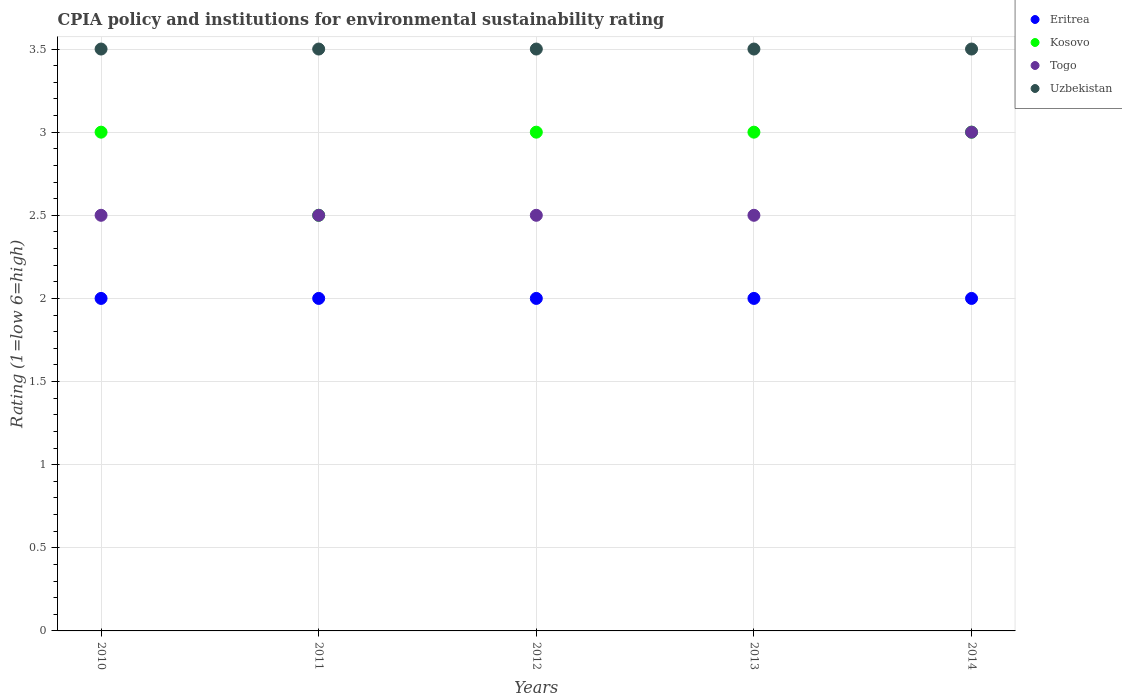Across all years, what is the maximum CPIA rating in Uzbekistan?
Make the answer very short. 3.5. Across all years, what is the minimum CPIA rating in Eritrea?
Your answer should be very brief. 2. In which year was the CPIA rating in Eritrea maximum?
Give a very brief answer. 2010. In which year was the CPIA rating in Togo minimum?
Give a very brief answer. 2010. What is the total CPIA rating in Uzbekistan in the graph?
Offer a terse response. 17.5. What is the difference between the CPIA rating in Togo in 2010 and that in 2014?
Your response must be concise. -0.5. In the year 2012, what is the difference between the CPIA rating in Kosovo and CPIA rating in Eritrea?
Your response must be concise. 1. Is the CPIA rating in Togo in 2012 less than that in 2014?
Your response must be concise. Yes. What is the difference between the highest and the second highest CPIA rating in Togo?
Your response must be concise. 0.5. What is the difference between the highest and the lowest CPIA rating in Togo?
Make the answer very short. 0.5. Is it the case that in every year, the sum of the CPIA rating in Uzbekistan and CPIA rating in Togo  is greater than the CPIA rating in Eritrea?
Keep it short and to the point. Yes. Is the CPIA rating in Togo strictly greater than the CPIA rating in Eritrea over the years?
Give a very brief answer. Yes. Is the CPIA rating in Uzbekistan strictly less than the CPIA rating in Kosovo over the years?
Offer a terse response. No. How many dotlines are there?
Offer a very short reply. 4. How many years are there in the graph?
Your answer should be very brief. 5. Does the graph contain any zero values?
Your answer should be compact. No. Where does the legend appear in the graph?
Provide a short and direct response. Top right. How many legend labels are there?
Your answer should be compact. 4. How are the legend labels stacked?
Offer a very short reply. Vertical. What is the title of the graph?
Ensure brevity in your answer.  CPIA policy and institutions for environmental sustainability rating. Does "Jamaica" appear as one of the legend labels in the graph?
Your response must be concise. No. What is the Rating (1=low 6=high) in Eritrea in 2011?
Make the answer very short. 2. What is the Rating (1=low 6=high) of Kosovo in 2011?
Your response must be concise. 2.5. What is the Rating (1=low 6=high) of Togo in 2011?
Keep it short and to the point. 2.5. What is the Rating (1=low 6=high) in Kosovo in 2013?
Your answer should be very brief. 3. Across all years, what is the maximum Rating (1=low 6=high) of Kosovo?
Make the answer very short. 3. Across all years, what is the maximum Rating (1=low 6=high) of Togo?
Keep it short and to the point. 3. Across all years, what is the maximum Rating (1=low 6=high) of Uzbekistan?
Ensure brevity in your answer.  3.5. Across all years, what is the minimum Rating (1=low 6=high) in Kosovo?
Your answer should be very brief. 2.5. What is the total Rating (1=low 6=high) of Eritrea in the graph?
Offer a very short reply. 10. What is the total Rating (1=low 6=high) of Togo in the graph?
Make the answer very short. 13. What is the total Rating (1=low 6=high) of Uzbekistan in the graph?
Offer a very short reply. 17.5. What is the difference between the Rating (1=low 6=high) in Kosovo in 2010 and that in 2011?
Provide a succinct answer. 0.5. What is the difference between the Rating (1=low 6=high) in Uzbekistan in 2010 and that in 2011?
Your response must be concise. 0. What is the difference between the Rating (1=low 6=high) of Kosovo in 2010 and that in 2012?
Provide a succinct answer. 0. What is the difference between the Rating (1=low 6=high) of Togo in 2010 and that in 2012?
Offer a very short reply. 0. What is the difference between the Rating (1=low 6=high) in Uzbekistan in 2010 and that in 2012?
Make the answer very short. 0. What is the difference between the Rating (1=low 6=high) of Kosovo in 2010 and that in 2014?
Your answer should be very brief. 0. What is the difference between the Rating (1=low 6=high) in Uzbekistan in 2010 and that in 2014?
Offer a very short reply. 0. What is the difference between the Rating (1=low 6=high) in Eritrea in 2011 and that in 2012?
Give a very brief answer. 0. What is the difference between the Rating (1=low 6=high) of Togo in 2011 and that in 2012?
Provide a short and direct response. 0. What is the difference between the Rating (1=low 6=high) of Uzbekistan in 2011 and that in 2012?
Your response must be concise. 0. What is the difference between the Rating (1=low 6=high) of Eritrea in 2011 and that in 2013?
Provide a short and direct response. 0. What is the difference between the Rating (1=low 6=high) in Kosovo in 2011 and that in 2013?
Ensure brevity in your answer.  -0.5. What is the difference between the Rating (1=low 6=high) in Eritrea in 2012 and that in 2013?
Your response must be concise. 0. What is the difference between the Rating (1=low 6=high) in Kosovo in 2012 and that in 2013?
Keep it short and to the point. 0. What is the difference between the Rating (1=low 6=high) in Togo in 2012 and that in 2013?
Offer a terse response. 0. What is the difference between the Rating (1=low 6=high) in Uzbekistan in 2012 and that in 2013?
Offer a very short reply. 0. What is the difference between the Rating (1=low 6=high) in Togo in 2012 and that in 2014?
Provide a succinct answer. -0.5. What is the difference between the Rating (1=low 6=high) in Kosovo in 2013 and that in 2014?
Your response must be concise. 0. What is the difference between the Rating (1=low 6=high) in Togo in 2013 and that in 2014?
Give a very brief answer. -0.5. What is the difference between the Rating (1=low 6=high) in Eritrea in 2010 and the Rating (1=low 6=high) in Togo in 2011?
Provide a short and direct response. -0.5. What is the difference between the Rating (1=low 6=high) in Kosovo in 2010 and the Rating (1=low 6=high) in Uzbekistan in 2011?
Your response must be concise. -0.5. What is the difference between the Rating (1=low 6=high) in Eritrea in 2010 and the Rating (1=low 6=high) in Togo in 2012?
Keep it short and to the point. -0.5. What is the difference between the Rating (1=low 6=high) in Eritrea in 2010 and the Rating (1=low 6=high) in Uzbekistan in 2012?
Provide a short and direct response. -1.5. What is the difference between the Rating (1=low 6=high) of Kosovo in 2010 and the Rating (1=low 6=high) of Uzbekistan in 2012?
Your answer should be compact. -0.5. What is the difference between the Rating (1=low 6=high) of Eritrea in 2010 and the Rating (1=low 6=high) of Togo in 2013?
Your response must be concise. -0.5. What is the difference between the Rating (1=low 6=high) in Eritrea in 2010 and the Rating (1=low 6=high) in Uzbekistan in 2013?
Keep it short and to the point. -1.5. What is the difference between the Rating (1=low 6=high) of Kosovo in 2010 and the Rating (1=low 6=high) of Uzbekistan in 2013?
Offer a very short reply. -0.5. What is the difference between the Rating (1=low 6=high) of Eritrea in 2010 and the Rating (1=low 6=high) of Kosovo in 2014?
Make the answer very short. -1. What is the difference between the Rating (1=low 6=high) of Kosovo in 2010 and the Rating (1=low 6=high) of Togo in 2014?
Keep it short and to the point. 0. What is the difference between the Rating (1=low 6=high) in Togo in 2010 and the Rating (1=low 6=high) in Uzbekistan in 2014?
Provide a short and direct response. -1. What is the difference between the Rating (1=low 6=high) in Eritrea in 2011 and the Rating (1=low 6=high) in Togo in 2012?
Ensure brevity in your answer.  -0.5. What is the difference between the Rating (1=low 6=high) of Kosovo in 2011 and the Rating (1=low 6=high) of Togo in 2012?
Provide a short and direct response. 0. What is the difference between the Rating (1=low 6=high) in Togo in 2011 and the Rating (1=low 6=high) in Uzbekistan in 2012?
Offer a terse response. -1. What is the difference between the Rating (1=low 6=high) of Eritrea in 2011 and the Rating (1=low 6=high) of Kosovo in 2013?
Your response must be concise. -1. What is the difference between the Rating (1=low 6=high) in Eritrea in 2011 and the Rating (1=low 6=high) in Togo in 2013?
Offer a very short reply. -0.5. What is the difference between the Rating (1=low 6=high) of Eritrea in 2011 and the Rating (1=low 6=high) of Uzbekistan in 2013?
Offer a terse response. -1.5. What is the difference between the Rating (1=low 6=high) in Kosovo in 2011 and the Rating (1=low 6=high) in Uzbekistan in 2013?
Give a very brief answer. -1. What is the difference between the Rating (1=low 6=high) in Eritrea in 2011 and the Rating (1=low 6=high) in Togo in 2014?
Make the answer very short. -1. What is the difference between the Rating (1=low 6=high) in Kosovo in 2011 and the Rating (1=low 6=high) in Togo in 2014?
Offer a very short reply. -0.5. What is the difference between the Rating (1=low 6=high) in Kosovo in 2011 and the Rating (1=low 6=high) in Uzbekistan in 2014?
Provide a short and direct response. -1. What is the difference between the Rating (1=low 6=high) in Eritrea in 2012 and the Rating (1=low 6=high) in Uzbekistan in 2013?
Keep it short and to the point. -1.5. What is the difference between the Rating (1=low 6=high) of Kosovo in 2012 and the Rating (1=low 6=high) of Togo in 2013?
Your response must be concise. 0.5. What is the difference between the Rating (1=low 6=high) in Togo in 2012 and the Rating (1=low 6=high) in Uzbekistan in 2013?
Make the answer very short. -1. What is the difference between the Rating (1=low 6=high) of Eritrea in 2012 and the Rating (1=low 6=high) of Togo in 2014?
Provide a succinct answer. -1. What is the difference between the Rating (1=low 6=high) of Eritrea in 2012 and the Rating (1=low 6=high) of Uzbekistan in 2014?
Ensure brevity in your answer.  -1.5. What is the difference between the Rating (1=low 6=high) of Kosovo in 2012 and the Rating (1=low 6=high) of Uzbekistan in 2014?
Give a very brief answer. -0.5. What is the difference between the Rating (1=low 6=high) of Eritrea in 2013 and the Rating (1=low 6=high) of Kosovo in 2014?
Offer a very short reply. -1. What is the difference between the Rating (1=low 6=high) in Eritrea in 2013 and the Rating (1=low 6=high) in Uzbekistan in 2014?
Make the answer very short. -1.5. What is the difference between the Rating (1=low 6=high) of Kosovo in 2013 and the Rating (1=low 6=high) of Uzbekistan in 2014?
Ensure brevity in your answer.  -0.5. What is the difference between the Rating (1=low 6=high) of Togo in 2013 and the Rating (1=low 6=high) of Uzbekistan in 2014?
Keep it short and to the point. -1. What is the average Rating (1=low 6=high) in Kosovo per year?
Make the answer very short. 2.9. What is the average Rating (1=low 6=high) of Uzbekistan per year?
Provide a short and direct response. 3.5. In the year 2010, what is the difference between the Rating (1=low 6=high) in Eritrea and Rating (1=low 6=high) in Kosovo?
Provide a succinct answer. -1. In the year 2010, what is the difference between the Rating (1=low 6=high) of Eritrea and Rating (1=low 6=high) of Uzbekistan?
Your response must be concise. -1.5. In the year 2011, what is the difference between the Rating (1=low 6=high) in Eritrea and Rating (1=low 6=high) in Togo?
Your response must be concise. -0.5. In the year 2011, what is the difference between the Rating (1=low 6=high) of Kosovo and Rating (1=low 6=high) of Togo?
Your answer should be very brief. 0. In the year 2012, what is the difference between the Rating (1=low 6=high) in Eritrea and Rating (1=low 6=high) in Kosovo?
Provide a short and direct response. -1. In the year 2012, what is the difference between the Rating (1=low 6=high) in Eritrea and Rating (1=low 6=high) in Togo?
Make the answer very short. -0.5. In the year 2013, what is the difference between the Rating (1=low 6=high) in Eritrea and Rating (1=low 6=high) in Kosovo?
Provide a succinct answer. -1. In the year 2013, what is the difference between the Rating (1=low 6=high) in Eritrea and Rating (1=low 6=high) in Uzbekistan?
Provide a short and direct response. -1.5. In the year 2013, what is the difference between the Rating (1=low 6=high) of Kosovo and Rating (1=low 6=high) of Togo?
Make the answer very short. 0.5. In the year 2014, what is the difference between the Rating (1=low 6=high) in Eritrea and Rating (1=low 6=high) in Togo?
Offer a very short reply. -1. In the year 2014, what is the difference between the Rating (1=low 6=high) in Eritrea and Rating (1=low 6=high) in Uzbekistan?
Offer a very short reply. -1.5. What is the ratio of the Rating (1=low 6=high) in Kosovo in 2010 to that in 2011?
Make the answer very short. 1.2. What is the ratio of the Rating (1=low 6=high) of Togo in 2010 to that in 2011?
Provide a succinct answer. 1. What is the ratio of the Rating (1=low 6=high) of Eritrea in 2010 to that in 2012?
Give a very brief answer. 1. What is the ratio of the Rating (1=low 6=high) in Kosovo in 2010 to that in 2012?
Ensure brevity in your answer.  1. What is the ratio of the Rating (1=low 6=high) in Eritrea in 2010 to that in 2013?
Offer a terse response. 1. What is the ratio of the Rating (1=low 6=high) of Kosovo in 2010 to that in 2013?
Keep it short and to the point. 1. What is the ratio of the Rating (1=low 6=high) of Uzbekistan in 2010 to that in 2013?
Your answer should be very brief. 1. What is the ratio of the Rating (1=low 6=high) in Eritrea in 2010 to that in 2014?
Your response must be concise. 1. What is the ratio of the Rating (1=low 6=high) in Kosovo in 2011 to that in 2012?
Offer a terse response. 0.83. What is the ratio of the Rating (1=low 6=high) in Kosovo in 2012 to that in 2013?
Give a very brief answer. 1. What is the ratio of the Rating (1=low 6=high) in Togo in 2012 to that in 2013?
Provide a short and direct response. 1. What is the ratio of the Rating (1=low 6=high) in Uzbekistan in 2012 to that in 2013?
Your response must be concise. 1. What is the ratio of the Rating (1=low 6=high) of Kosovo in 2012 to that in 2014?
Provide a short and direct response. 1. What is the ratio of the Rating (1=low 6=high) of Uzbekistan in 2012 to that in 2014?
Offer a terse response. 1. What is the ratio of the Rating (1=low 6=high) of Eritrea in 2013 to that in 2014?
Ensure brevity in your answer.  1. What is the ratio of the Rating (1=low 6=high) of Togo in 2013 to that in 2014?
Make the answer very short. 0.83. What is the difference between the highest and the second highest Rating (1=low 6=high) of Eritrea?
Your answer should be compact. 0. What is the difference between the highest and the lowest Rating (1=low 6=high) in Togo?
Ensure brevity in your answer.  0.5. What is the difference between the highest and the lowest Rating (1=low 6=high) of Uzbekistan?
Offer a very short reply. 0. 